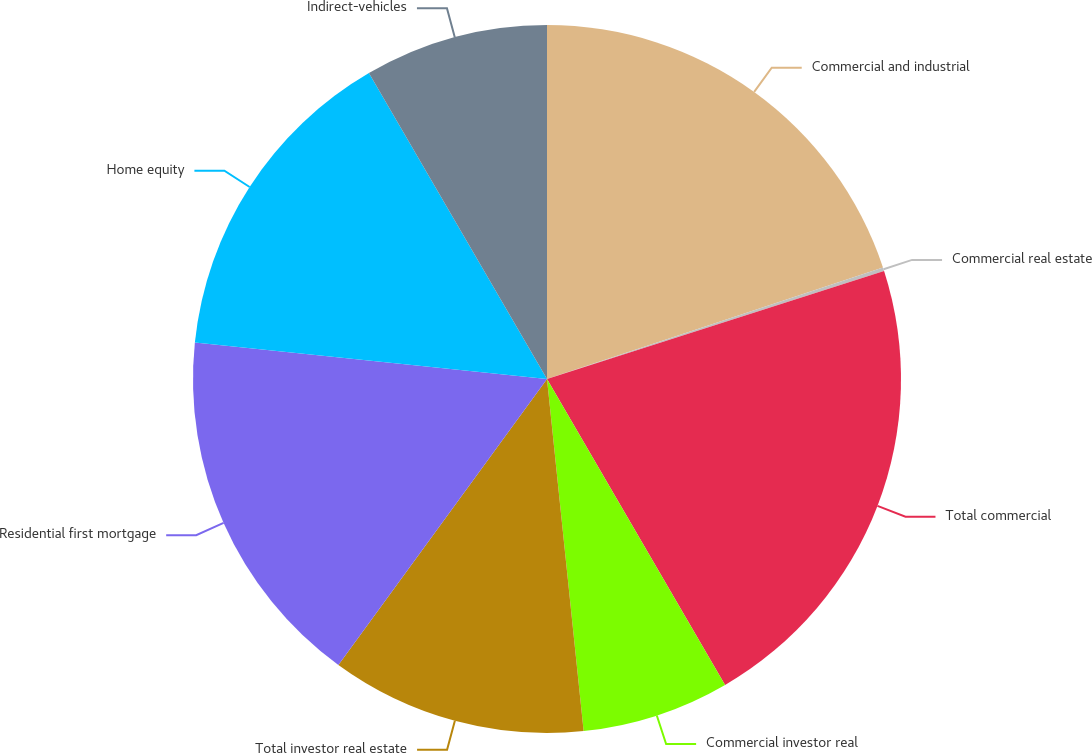Convert chart to OTSL. <chart><loc_0><loc_0><loc_500><loc_500><pie_chart><fcel>Commercial and industrial<fcel>Commercial real estate<fcel>Total commercial<fcel>Commercial investor real<fcel>Total investor real estate<fcel>Residential first mortgage<fcel>Home equity<fcel>Indirect-vehicles<nl><fcel>19.9%<fcel>0.16%<fcel>21.55%<fcel>6.74%<fcel>11.68%<fcel>16.61%<fcel>14.97%<fcel>8.39%<nl></chart> 